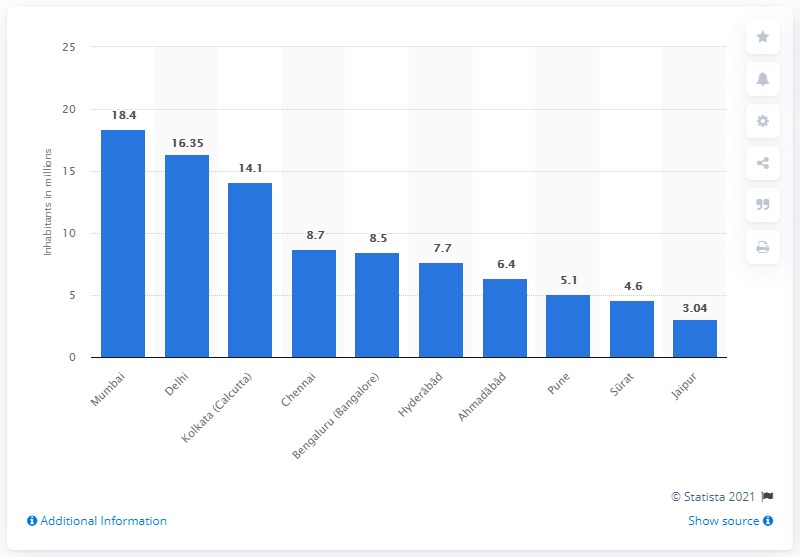Highlight a few significant elements in this photo. Mumbai is India's most populous city. 